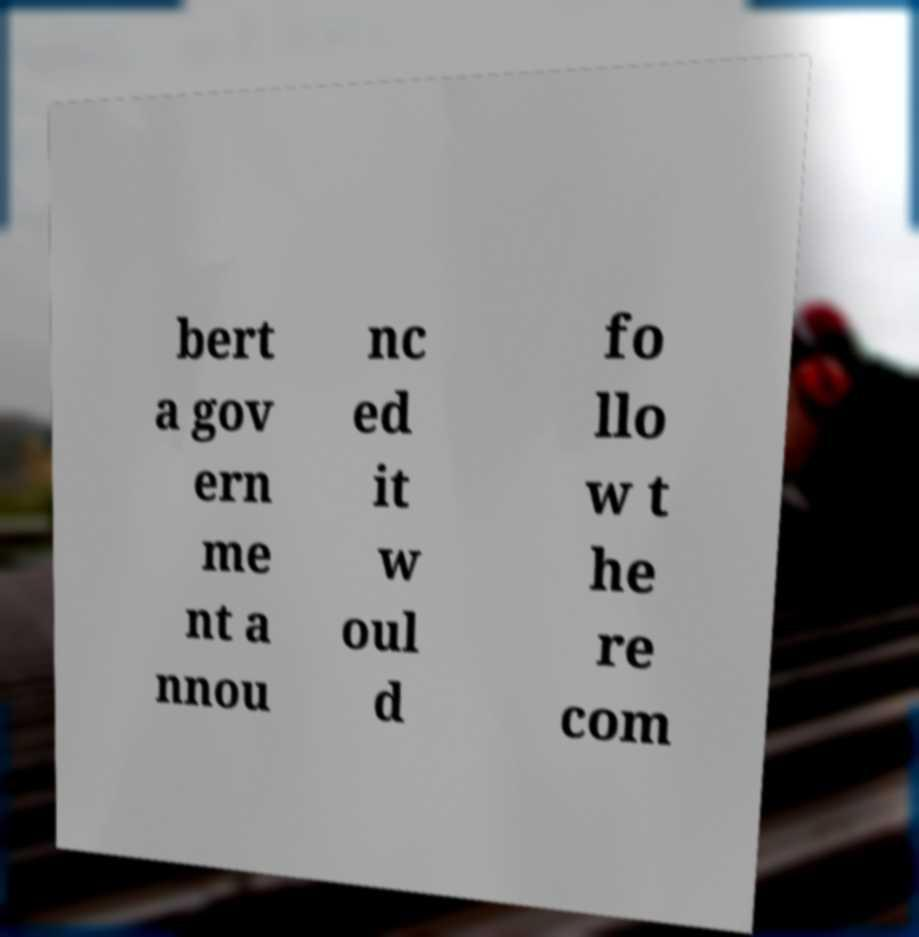What messages or text are displayed in this image? I need them in a readable, typed format. bert a gov ern me nt a nnou nc ed it w oul d fo llo w t he re com 